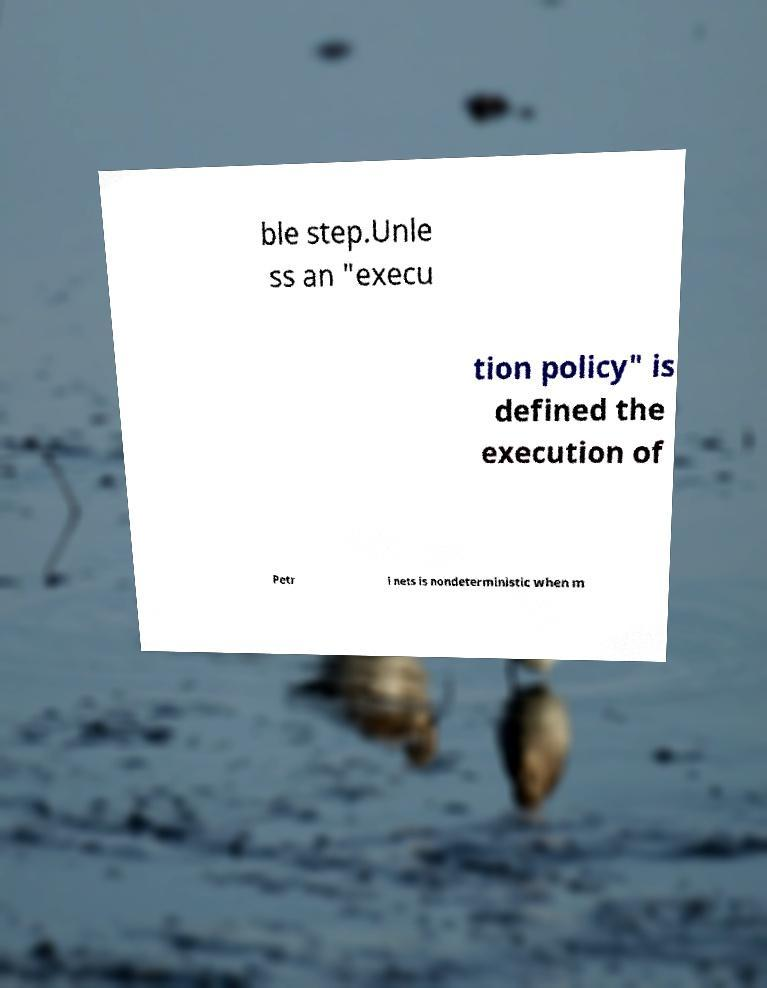What messages or text are displayed in this image? I need them in a readable, typed format. ble step.Unle ss an "execu tion policy" is defined the execution of Petr i nets is nondeterministic when m 